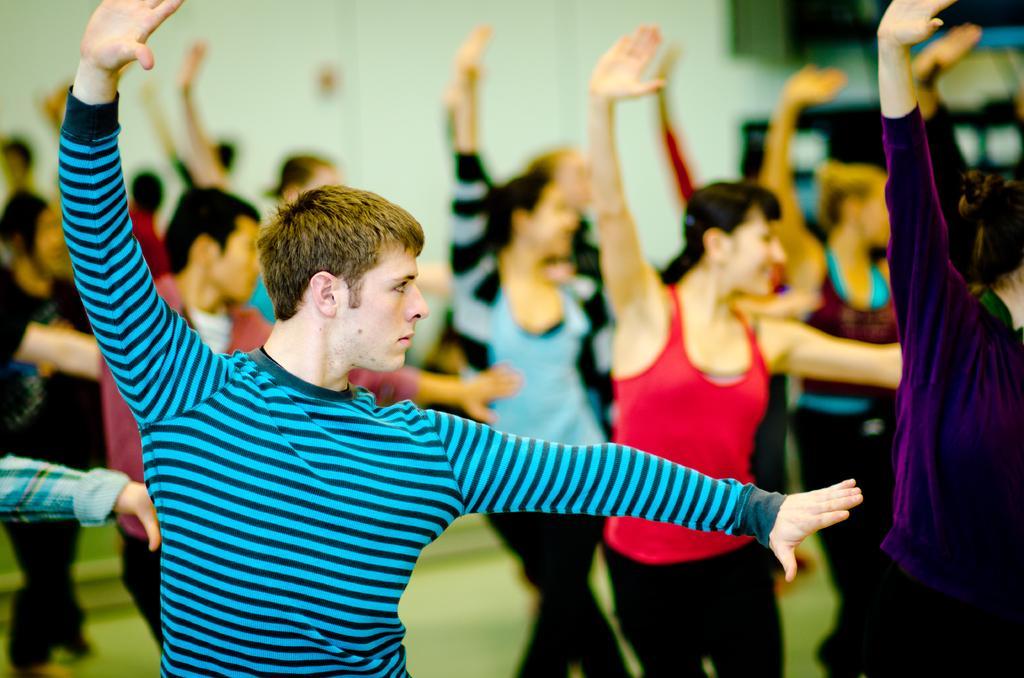Could you give a brief overview of what you see in this image? In this picture we can see there is a group of people dancing on the floor. Behind the people, there is the blurred background. 